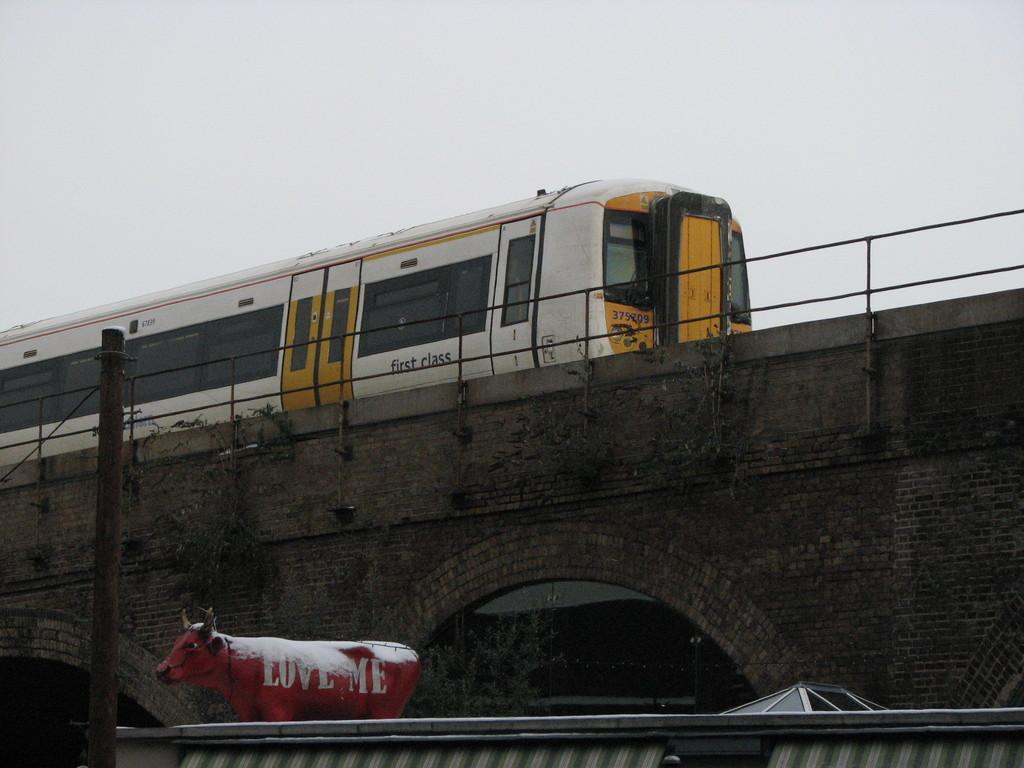What is the main subject of the image? The main subject of the image is a train on a bridge. What other objects or structures can be seen in the image? There is a fence, a pole, a statue of a buffalo, a roof, and the sky visible in the image. How many rings are visible on the statue of the buffalo in the image? There is no mention of rings on the statue of the buffalo in the image; it is a statue of a buffalo without any rings. 